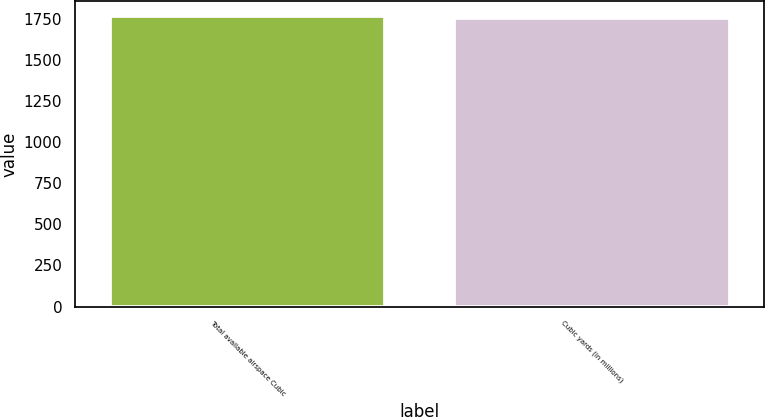Convert chart. <chart><loc_0><loc_0><loc_500><loc_500><bar_chart><fcel>Total available airspace Cubic<fcel>Cubic yards (in millions)<nl><fcel>1767.3<fcel>1755.4<nl></chart> 